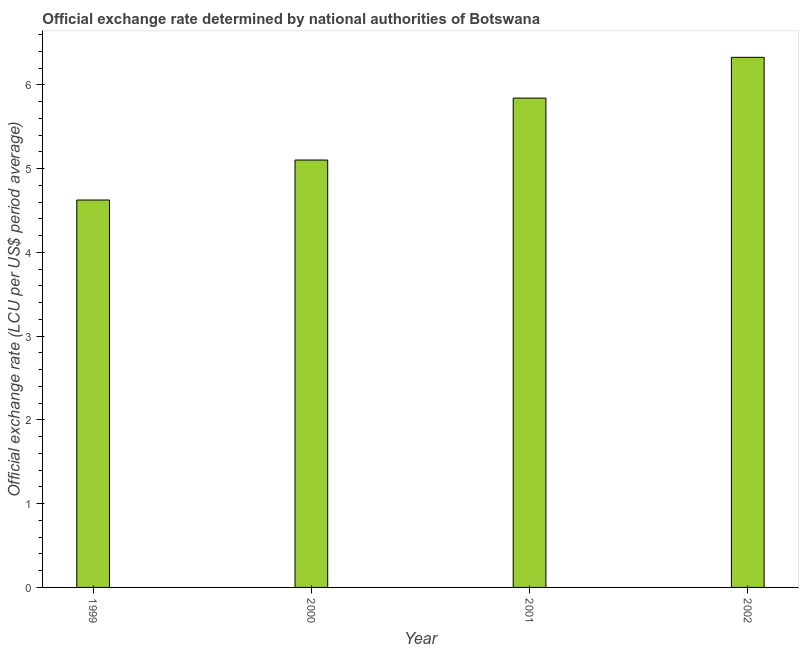Does the graph contain any zero values?
Keep it short and to the point. No. What is the title of the graph?
Keep it short and to the point. Official exchange rate determined by national authorities of Botswana. What is the label or title of the X-axis?
Your answer should be very brief. Year. What is the label or title of the Y-axis?
Give a very brief answer. Official exchange rate (LCU per US$ period average). What is the official exchange rate in 2000?
Offer a very short reply. 5.1. Across all years, what is the maximum official exchange rate?
Offer a very short reply. 6.33. Across all years, what is the minimum official exchange rate?
Offer a terse response. 4.62. In which year was the official exchange rate minimum?
Provide a short and direct response. 1999. What is the sum of the official exchange rate?
Make the answer very short. 21.9. What is the difference between the official exchange rate in 2000 and 2002?
Give a very brief answer. -1.23. What is the average official exchange rate per year?
Offer a terse response. 5.47. What is the median official exchange rate?
Your answer should be very brief. 5.47. In how many years, is the official exchange rate greater than 2.8 ?
Give a very brief answer. 4. What is the ratio of the official exchange rate in 1999 to that in 2000?
Make the answer very short. 0.91. What is the difference between the highest and the second highest official exchange rate?
Keep it short and to the point. 0.49. Is the sum of the official exchange rate in 1999 and 2001 greater than the maximum official exchange rate across all years?
Your answer should be compact. Yes. Are all the bars in the graph horizontal?
Your answer should be very brief. No. What is the difference between two consecutive major ticks on the Y-axis?
Make the answer very short. 1. Are the values on the major ticks of Y-axis written in scientific E-notation?
Provide a succinct answer. No. What is the Official exchange rate (LCU per US$ period average) of 1999?
Your response must be concise. 4.62. What is the Official exchange rate (LCU per US$ period average) in 2000?
Your answer should be very brief. 5.1. What is the Official exchange rate (LCU per US$ period average) in 2001?
Give a very brief answer. 5.84. What is the Official exchange rate (LCU per US$ period average) of 2002?
Offer a terse response. 6.33. What is the difference between the Official exchange rate (LCU per US$ period average) in 1999 and 2000?
Give a very brief answer. -0.48. What is the difference between the Official exchange rate (LCU per US$ period average) in 1999 and 2001?
Give a very brief answer. -1.22. What is the difference between the Official exchange rate (LCU per US$ period average) in 1999 and 2002?
Offer a very short reply. -1.7. What is the difference between the Official exchange rate (LCU per US$ period average) in 2000 and 2001?
Provide a succinct answer. -0.74. What is the difference between the Official exchange rate (LCU per US$ period average) in 2000 and 2002?
Provide a short and direct response. -1.23. What is the difference between the Official exchange rate (LCU per US$ period average) in 2001 and 2002?
Your response must be concise. -0.49. What is the ratio of the Official exchange rate (LCU per US$ period average) in 1999 to that in 2000?
Your answer should be compact. 0.91. What is the ratio of the Official exchange rate (LCU per US$ period average) in 1999 to that in 2001?
Offer a terse response. 0.79. What is the ratio of the Official exchange rate (LCU per US$ period average) in 1999 to that in 2002?
Keep it short and to the point. 0.73. What is the ratio of the Official exchange rate (LCU per US$ period average) in 2000 to that in 2001?
Offer a terse response. 0.87. What is the ratio of the Official exchange rate (LCU per US$ period average) in 2000 to that in 2002?
Provide a succinct answer. 0.81. What is the ratio of the Official exchange rate (LCU per US$ period average) in 2001 to that in 2002?
Your response must be concise. 0.92. 